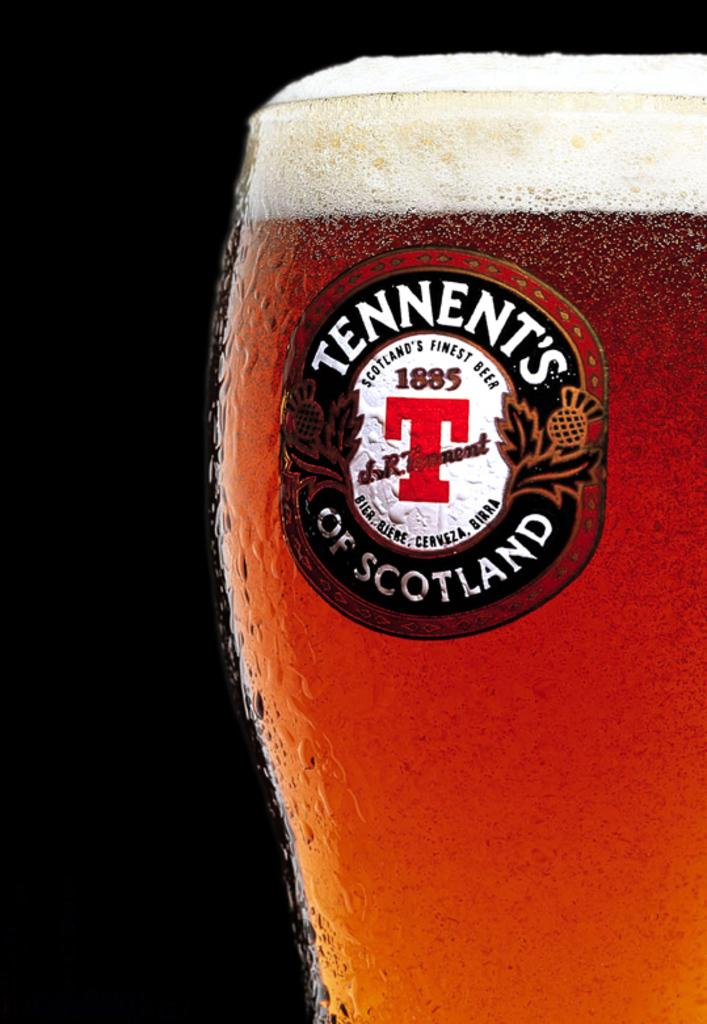Provide a one-sentence caption for the provided image. A mug of been with the words Tennent's of Scotland on the label. 